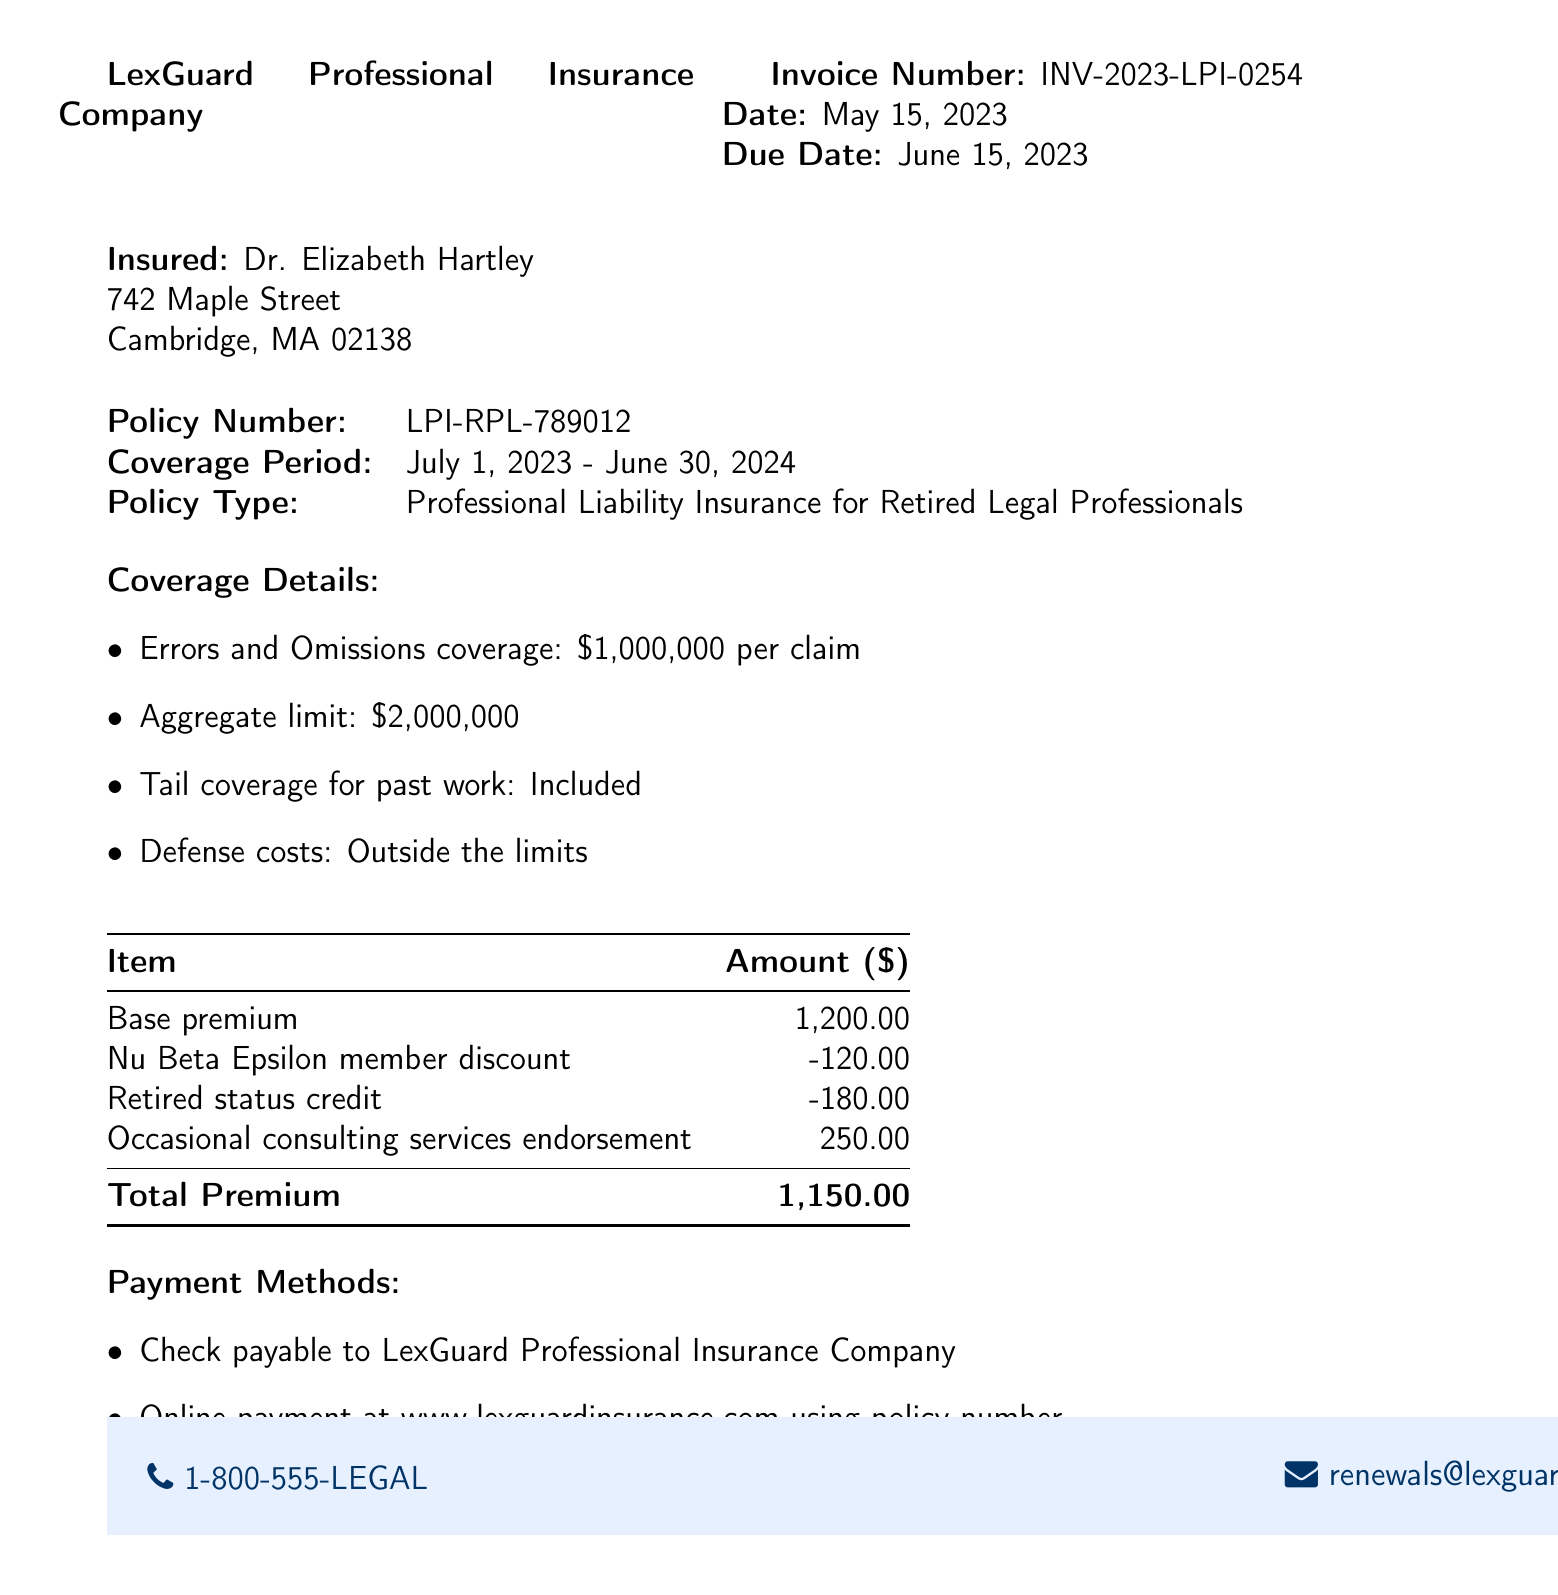What is the name of the insurance company? The insurance company is identified in the document as LexGuard Professional Insurance Company.
Answer: LexGuard Professional Insurance Company What is the invoice number? The document specifies the invoice number as INV-2023-LPI-0254.
Answer: INV-2023-LPI-0254 What is the due date for the invoice? The invoice details indicate that the due date is June 15, 2023.
Answer: June 15, 2023 What is the total premium amount? The total premium amount is provided at the end of the premium breakdown as 1,150.00.
Answer: 1,150.00 What discounts are applied in the invoice? Discounts are detailed as follows: Nu Beta Epsilon member discount and retired status credit, totaling to -300.00.
Answer: Nu Beta Epsilon member discount and retired status credit What is the coverage period for this policy? The document specifies the coverage period as July 1, 2023 - June 30, 2024.
Answer: July 1, 2023 - June 30, 2024 What type of insurance is this invoice for? The document states that this is for Professional Liability Insurance for Retired Legal Professionals.
Answer: Professional Liability Insurance for Retired Legal Professionals What methods of payment are available? Payment methods include check and online payment at the specified website.
Answer: Check and online payment How can I contact the insurance company? The contact information at the bottom provides a phone number and an email address for renewals.
Answer: 1-800-555-LEGAL and renewals@lexguardinsurance.com 